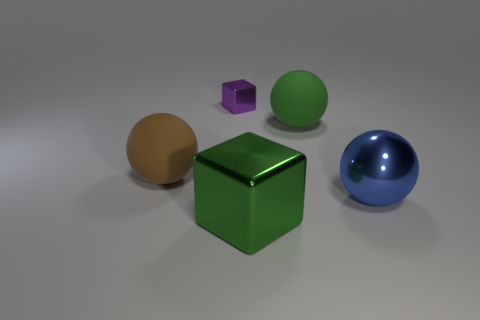Subtract 1 balls. How many balls are left? 2 Add 1 large green objects. How many objects exist? 6 Subtract all spheres. How many objects are left? 2 Subtract 1 blue balls. How many objects are left? 4 Subtract all tiny rubber blocks. Subtract all big brown things. How many objects are left? 4 Add 5 small purple blocks. How many small purple blocks are left? 6 Add 3 big brown rubber balls. How many big brown rubber balls exist? 4 